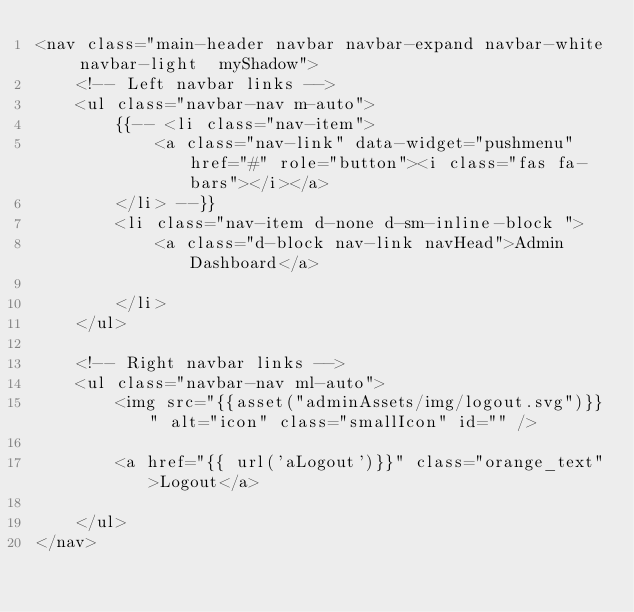<code> <loc_0><loc_0><loc_500><loc_500><_PHP_><nav class="main-header navbar navbar-expand navbar-white navbar-light  myShadow">
    <!-- Left navbar links -->
    <ul class="navbar-nav m-auto">
        {{-- <li class="nav-item">
            <a class="nav-link" data-widget="pushmenu" href="#" role="button"><i class="fas fa-bars"></i></a>
        </li> --}}
        <li class="nav-item d-none d-sm-inline-block ">
            <a class="d-block nav-link navHead">Admin Dashboard</a>

        </li>
    </ul>

    <!-- Right navbar links -->
    <ul class="navbar-nav ml-auto">
        <img src="{{asset("adminAssets/img/logout.svg")}}" alt="icon" class="smallIcon" id="" />

        <a href="{{ url('aLogout')}}" class="orange_text">Logout</a>

    </ul>
</nav></code> 